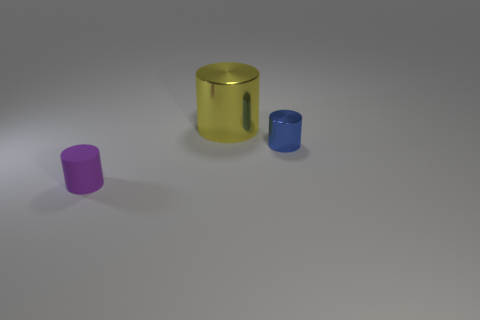Are there any other things that have the same size as the yellow metallic thing?
Your answer should be very brief. No. What material is the big yellow object?
Offer a very short reply. Metal. What is the color of the metal object that is behind the blue shiny cylinder?
Give a very brief answer. Yellow. Is the number of small cylinders right of the matte thing greater than the number of tiny purple cylinders that are right of the tiny blue metallic cylinder?
Provide a succinct answer. Yes. What is the size of the cylinder right of the shiny object behind the tiny cylinder behind the matte cylinder?
Your answer should be compact. Small. How many big green matte objects are there?
Provide a short and direct response. 0. There is a small cylinder that is left of the metallic cylinder that is behind the small cylinder that is behind the tiny matte cylinder; what is it made of?
Your answer should be compact. Rubber. Is there a big red thing made of the same material as the blue cylinder?
Offer a terse response. No. Are the big yellow thing and the purple cylinder made of the same material?
Offer a very short reply. No. How many cylinders are large things or tiny metallic things?
Provide a short and direct response. 2. 